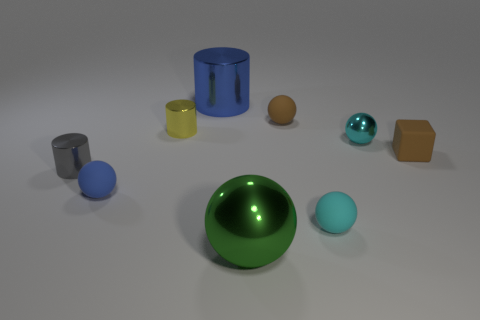Subtract all red spheres. Subtract all cyan cylinders. How many spheres are left? 5 Add 1 cyan spheres. How many objects exist? 10 Subtract all cylinders. How many objects are left? 6 Add 6 brown rubber objects. How many brown rubber objects are left? 8 Add 5 green metallic balls. How many green metallic balls exist? 6 Subtract 1 brown blocks. How many objects are left? 8 Subtract all blue things. Subtract all tiny green rubber cubes. How many objects are left? 7 